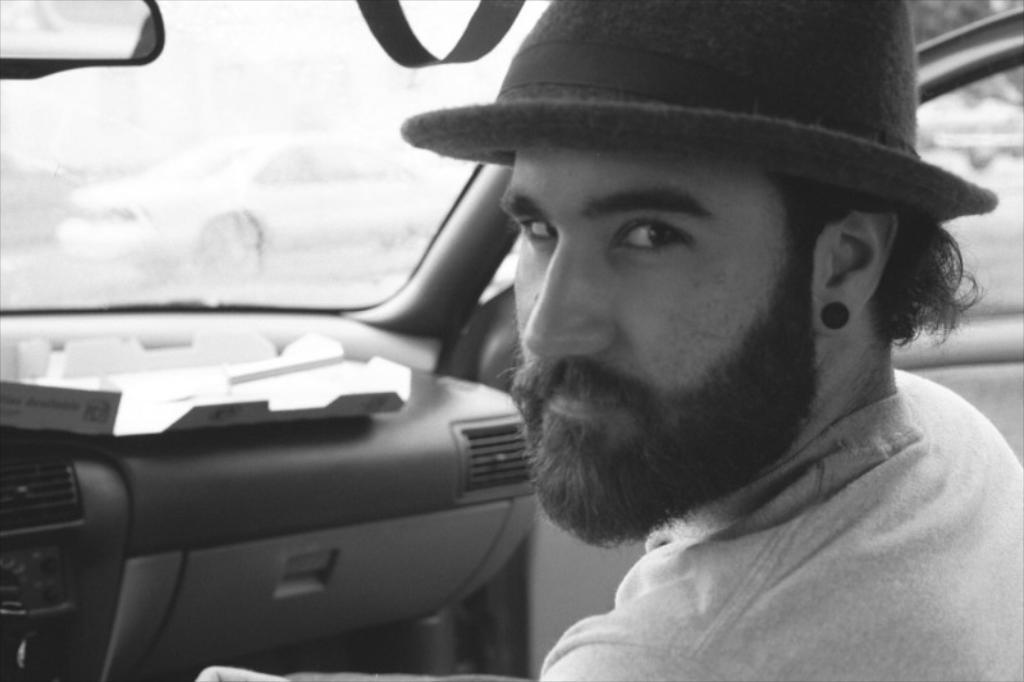What is the man in the image doing? The man is sitting in the image. What is the man wearing on his head? The man is wearing a hat. What is the status of the door in the image? The door is open. What is in front of the man? There is a windshield in front of the man. What trail of destruction does the man leave behind him in the image? There is no trail of destruction present in the image. 